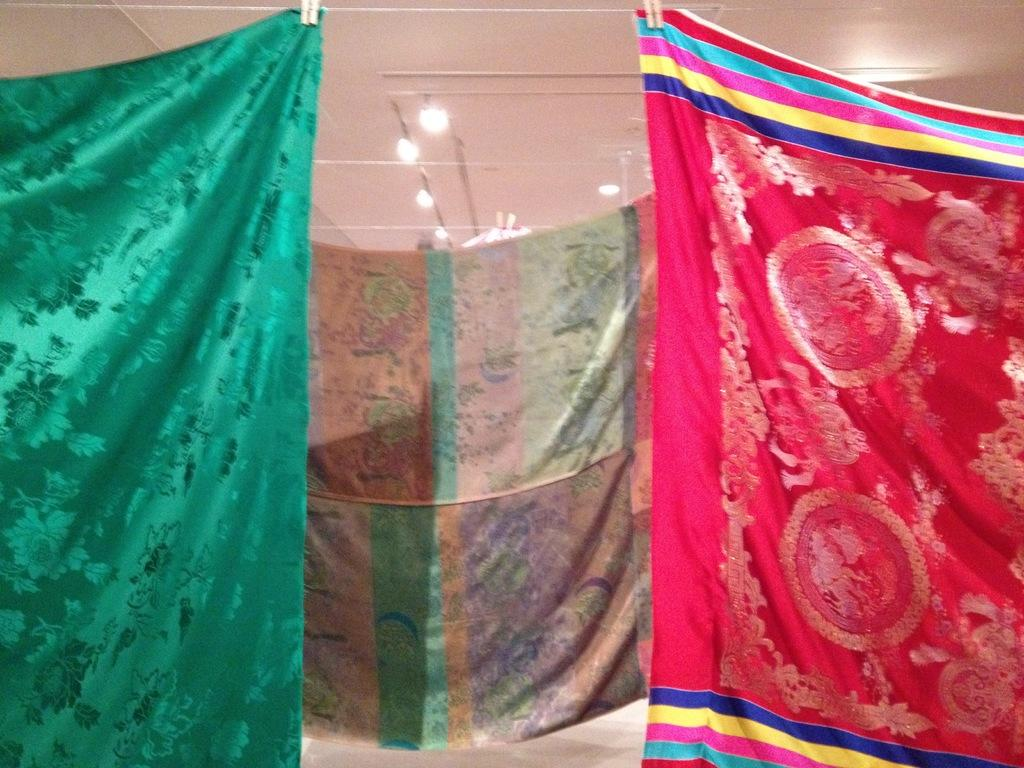What objects are present in the image? There are blankets in the image. How are the blankets arranged or positioned? The blankets are hanging onto a rope. What grade does the story in the image belong to? There is no story present in the image, as it only features blankets hanging onto a rope. 